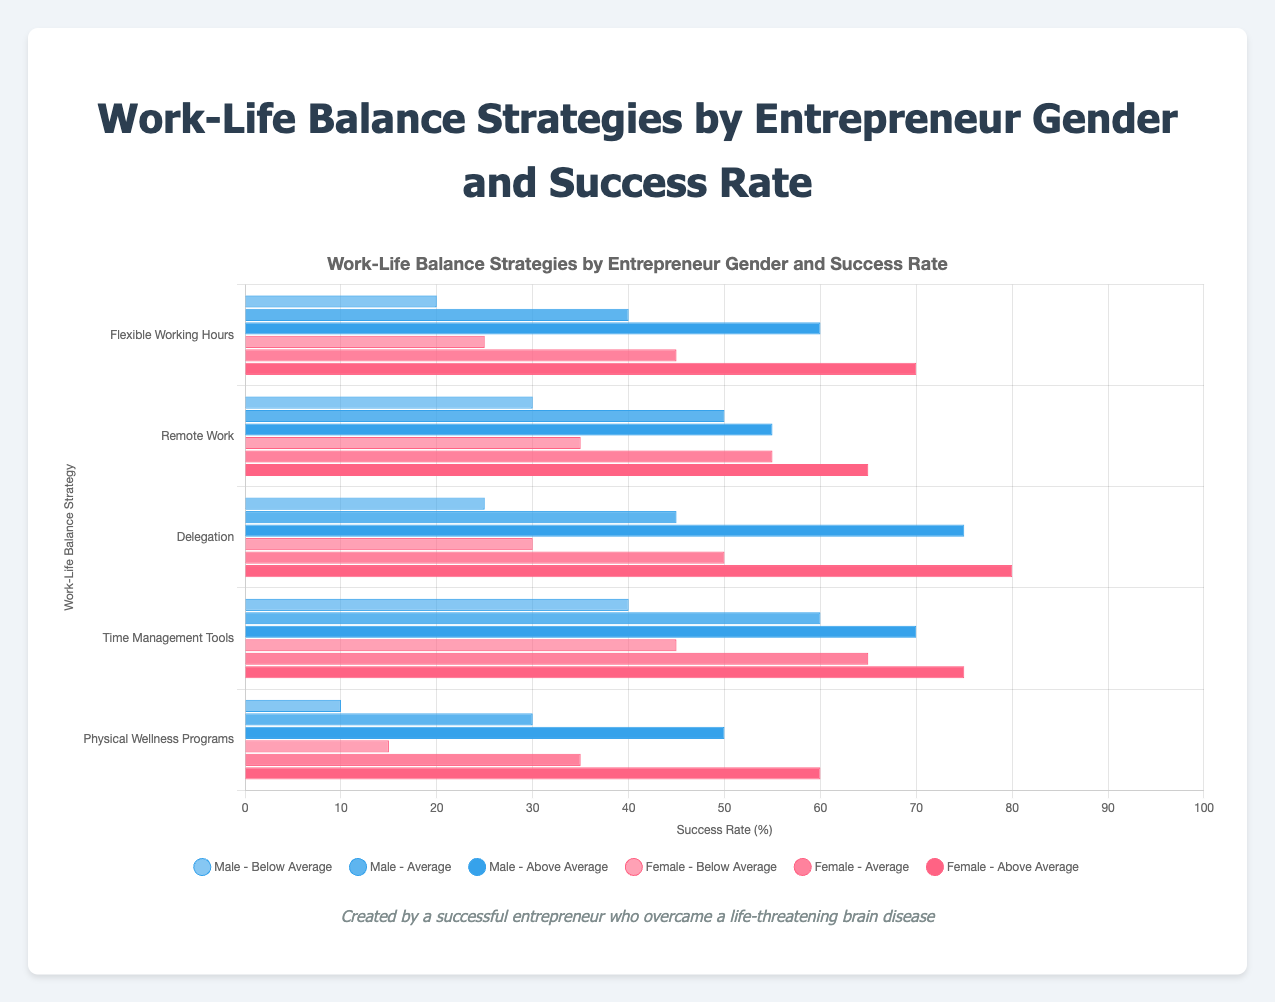Which Work-Life Balance Strategy has the highest percentage of Female Entrepreneurs with Above Average Success Rates? Look at the chart and find the bar representing Female Entrepreneurs with Above Average Success Rates for each strategy. The tallest bar in this category is "Delegation".
Answer: Delegation What is the difference in the percentage of Male and Female Entrepreneurs with Below Average Success Rates for Remote Work? Compare the "Below Average Success Rate" bars for Male and Female Entrepreneurs under "Remote Work". For males, it is 30%, and for females, it is 35%. The difference is 35% - 30% = 5%.
Answer: 5% Which strategy has the smallest gap between Male and Female Entrepreneurs for Average Success Rates? Check the "Average Success Rate" bars for each work-life balance strategy, comparing the gaps between male and female entrepreneurs. The smallest gap is for "Delegation" where males have 45% and females have 50%, a difference of 5%.
Answer: Delegation How many total Female Entrepreneurs have a Below Average Success Rate for all strategies combined? Add up the "Below Average Success Rate" for Female Entrepreneurs across all strategies. 25% (Flexible Working Hours) + 35% (Remote Work) + 30% (Delegation) + 45% (Time Management Tools) + 15% (Physical Wellness Programs) = 150%.
Answer: 150% Out of "Delegation" and "Time Management Tools", which strategy has a higher percentage of Male Entrepreneurs with Above Average Success Rates? Compare the "Above Average Success Rate" bars for Male Entrepreneurs between "Delegation" and "Time Management Tools". "Delegation" is 75% and "Time Management Tools" is 70%. "Delegation" is higher.
Answer: Delegation By how much does the percentage of Female Entrepreneurs with Above Average Success Rates for "Physical Wellness Programs" exceed that for Male Entrepreneurs? Compare the "Above Average Success Rate" bars for Male and Female Entrepreneurs under "Physical Wellness Programs". Female Entrepreneurs are at 60%, and Male Entrepreneurs are at 50%. The difference is 60% - 50% = 10%.
Answer: 10% Which gender has a higher success rate for "Flexible Working Hours" at all three success levels? Compare the heights of the bars at all three success levels (Below Average, Average, and Above Average) for "Flexible Working Hours" between Male and Female Entrepreneurs. In all three cases, female entrepreneurs have higher percentages (25% vs 20%, 45% vs 40%, 70% vs 60%).
Answer: Female For "Time Management Tools", what is the total percentage of Male Entrepreneurs with either Average or Above Average Success Rates? Add the "Average Success Rate" and "Above Average Success Rate" for Male Entrepreneurs under "Time Management Tools". 60% (Average) + 70% (Above Average) = 130%.
Answer: 130% In which Work-Life Balance Strategy do Female Entrepreneurs have the lowest percentage of Below Average Success Rates? Compare the "Below Average Success Rate" bars for Female Entrepreneurs across all strategies. The lowest percentage is 15% for "Physical Wellness Programs".
Answer: Physical Wellness Programs 